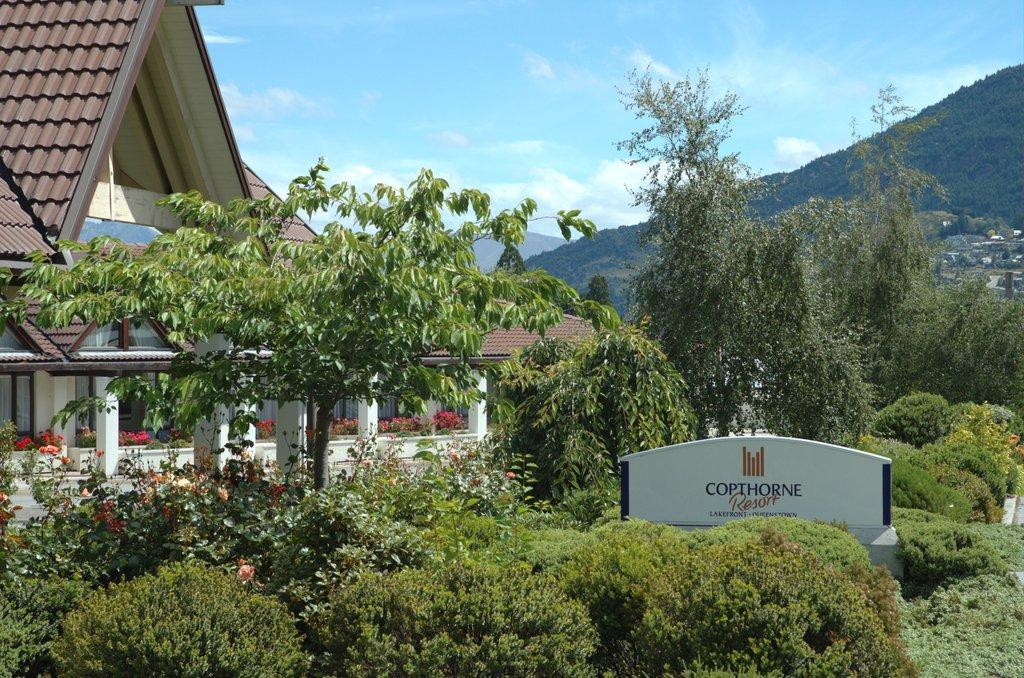What type of vegetation can be seen in the image? There are plants, trees, and flowers in the image. What type of structure is present in the image? There is a house in the image. What type of natural feature is visible in the image? There are hills in the image. What is visible at the top of the image? The sky is visible at the top of the image. Where is the hen located in the image? There is no hen present in the image. What type of light bulb is used in the house in the image? There is no information about the type of light bulb used in the house in the image. 